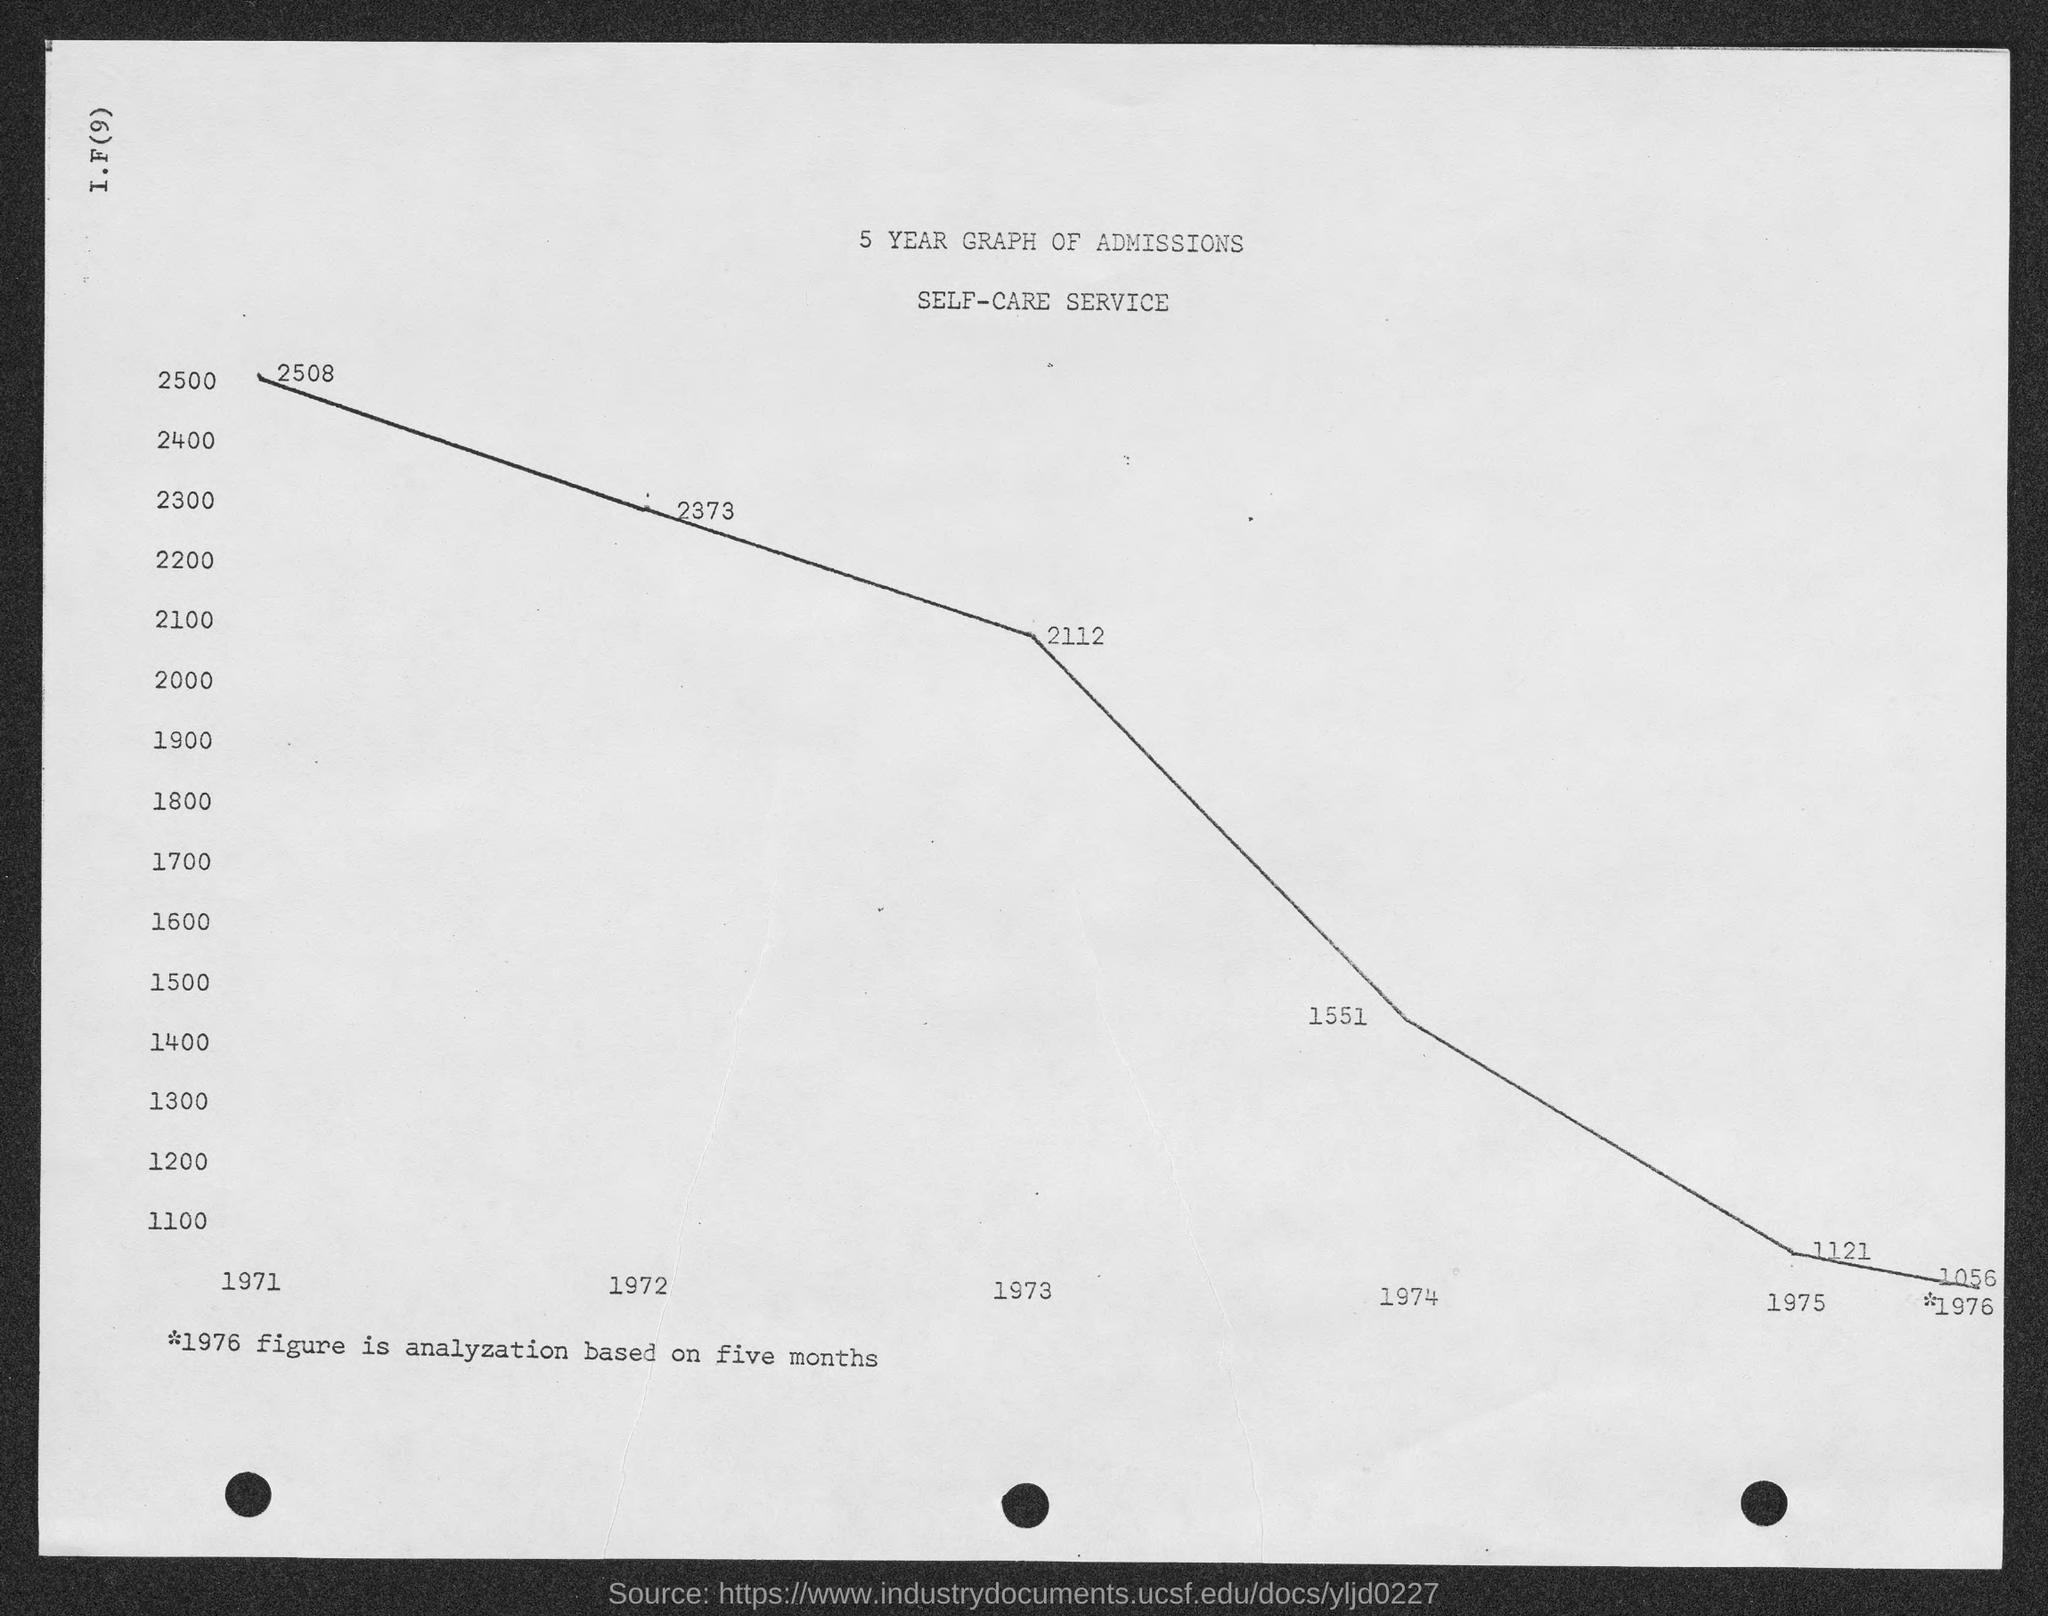Draw attention to some important aspects in this diagram. The value of admissions for the year 1973, as shown on the given page, is 2112. The value of admissions for the year 1972, as shown on the given page, is 2,373. The value of admissions for the year 1971, as shown on the given page, is 2508. The value of admissions for the year 1974, as shown on the given page, is 1551. 